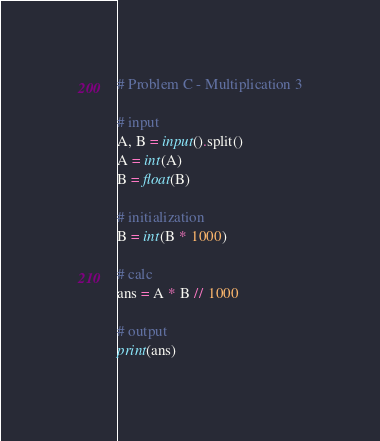<code> <loc_0><loc_0><loc_500><loc_500><_Python_># Problem C - Multiplication 3

# input
A, B = input().split()
A = int(A)
B = float(B)

# initialization
B = int(B * 1000)

# calc
ans = A * B // 1000

# output
print(ans)
</code> 